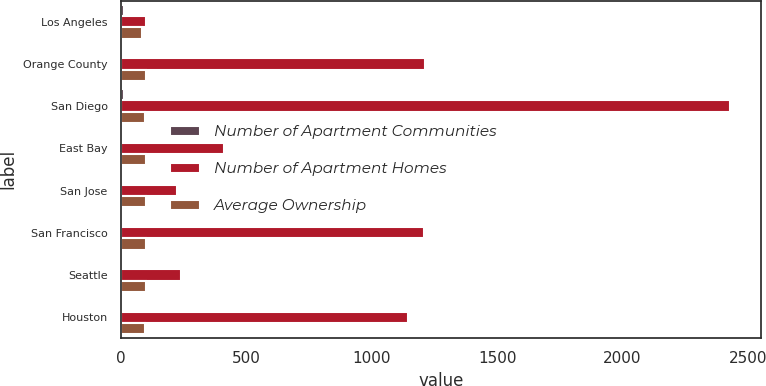Convert chart to OTSL. <chart><loc_0><loc_0><loc_500><loc_500><stacked_bar_chart><ecel><fcel>Los Angeles<fcel>Orange County<fcel>San Diego<fcel>East Bay<fcel>San Jose<fcel>San Francisco<fcel>Seattle<fcel>Houston<nl><fcel>Number of Apartment Communities<fcel>13<fcel>4<fcel>12<fcel>2<fcel>1<fcel>7<fcel>2<fcel>3<nl><fcel>Number of Apartment Homes<fcel>100<fcel>1213<fcel>2430<fcel>413<fcel>224<fcel>1208<fcel>239<fcel>1143<nl><fcel>Average Ownership<fcel>85<fcel>100<fcel>97<fcel>100<fcel>100<fcel>100<fcel>100<fcel>95<nl></chart> 